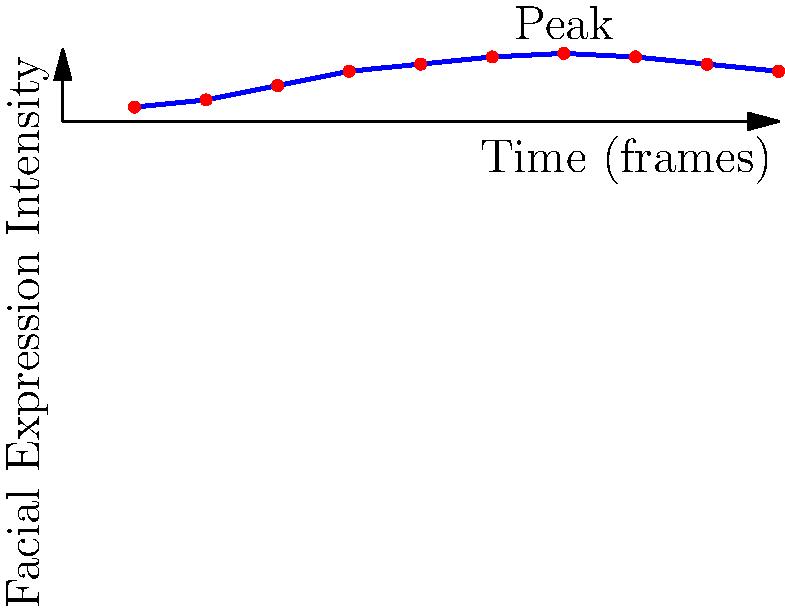In sign language video analysis, facial expressions play a crucial role in conveying meaning. The graph shows the intensity of a particular facial expression over 10 video frames. What machine learning technique would be most appropriate for identifying the peak of this facial expression, and how might this information be utilized in sign language research? To answer this question, let's break it down into steps:

1. Analyze the graph:
   The graph shows the intensity of a facial expression over time (10 frames). The intensity increases, reaches a peak, and then decreases.

2. Identify the appropriate machine learning technique:
   For this type of data, a time series analysis technique would be most appropriate. Specifically, peak detection algorithms within time series analysis would be ideal for identifying the maximum point of the facial expression intensity.

3. Suitable algorithms for peak detection:
   - Moving average
   - Savitzky-Golay filter
   - Continuous wavelet transform (CWT)

4. Application of peak detection:
   The chosen algorithm would analyze the time series data and identify the frame with the highest intensity (in this case, frame 7).

5. Utilization in sign language research:
   a) Temporal analysis: Understanding when facial expressions reach their peak can help in analyzing the timing and coordination of facial expressions with hand gestures in sign language.
   
   b) Emotion intensity: The peak intensity can indicate the strength of the emotion or emphasis being conveyed.
   
   c) Linguistic markers: Peaks in facial expressions might correspond to important linguistic elements, such as question markers or adverbial modifiers.
   
   d) Cross-linguistic comparisons: Researchers could compare peak timings and intensities across different sign languages to study universal and language-specific patterns.
   
   e) Automated recognition systems: This technique could be incorporated into sign language recognition systems to improve accuracy in interpreting the full meaning of signed communications.

6. Integration with other data:
   The peak detection of facial expressions would be combined with analysis of hand movements and body posture to create a comprehensive understanding of the sign language communication.
Answer: Time series analysis with peak detection algorithms; utilized for temporal coordination, emotion intensity, linguistic markers, cross-linguistic comparisons, and improving automated recognition systems. 